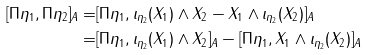<formula> <loc_0><loc_0><loc_500><loc_500>[ \Pi \eta _ { 1 } , \Pi \eta _ { 2 } ] _ { A } = & [ \Pi \eta _ { 1 } , \iota _ { \eta _ { 2 } } ( X _ { 1 } ) \wedge X _ { 2 } - X _ { 1 } \wedge \iota _ { \eta _ { 2 } } ( X _ { 2 } ) ] _ { A } \\ = & [ \Pi \eta _ { 1 } , \iota _ { \eta _ { 2 } } ( X _ { 1 } ) \wedge X _ { 2 } ] _ { A } - [ \Pi \eta _ { 1 } , X _ { 1 } \wedge \iota _ { \eta _ { 2 } } ( X _ { 2 } ) ] _ { A }</formula> 